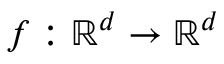Convert formula to latex. <formula><loc_0><loc_0><loc_500><loc_500>f \colon \mathbb { R } ^ { d } \to \mathbb { R } ^ { d }</formula> 